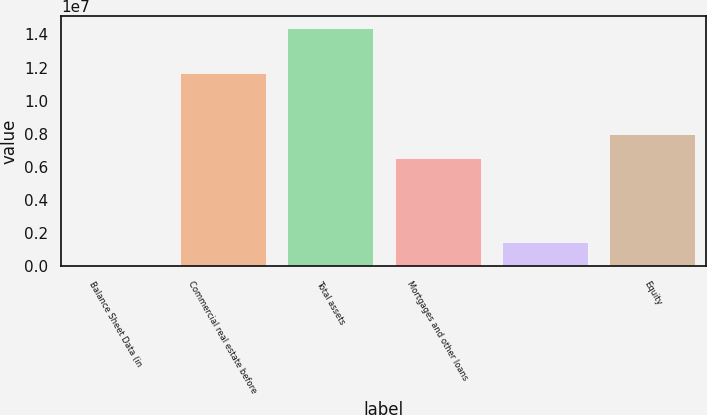Convert chart to OTSL. <chart><loc_0><loc_0><loc_500><loc_500><bar_chart><fcel>Balance Sheet Data (in<fcel>Commercial real estate before<fcel>Total assets<fcel>Mortgages and other loans<fcel>Unnamed: 4<fcel>Equity<nl><fcel>2012<fcel>1.1663e+07<fcel>1.43878e+07<fcel>6.52042e+06<fcel>1.44059e+06<fcel>7.95899e+06<nl></chart> 